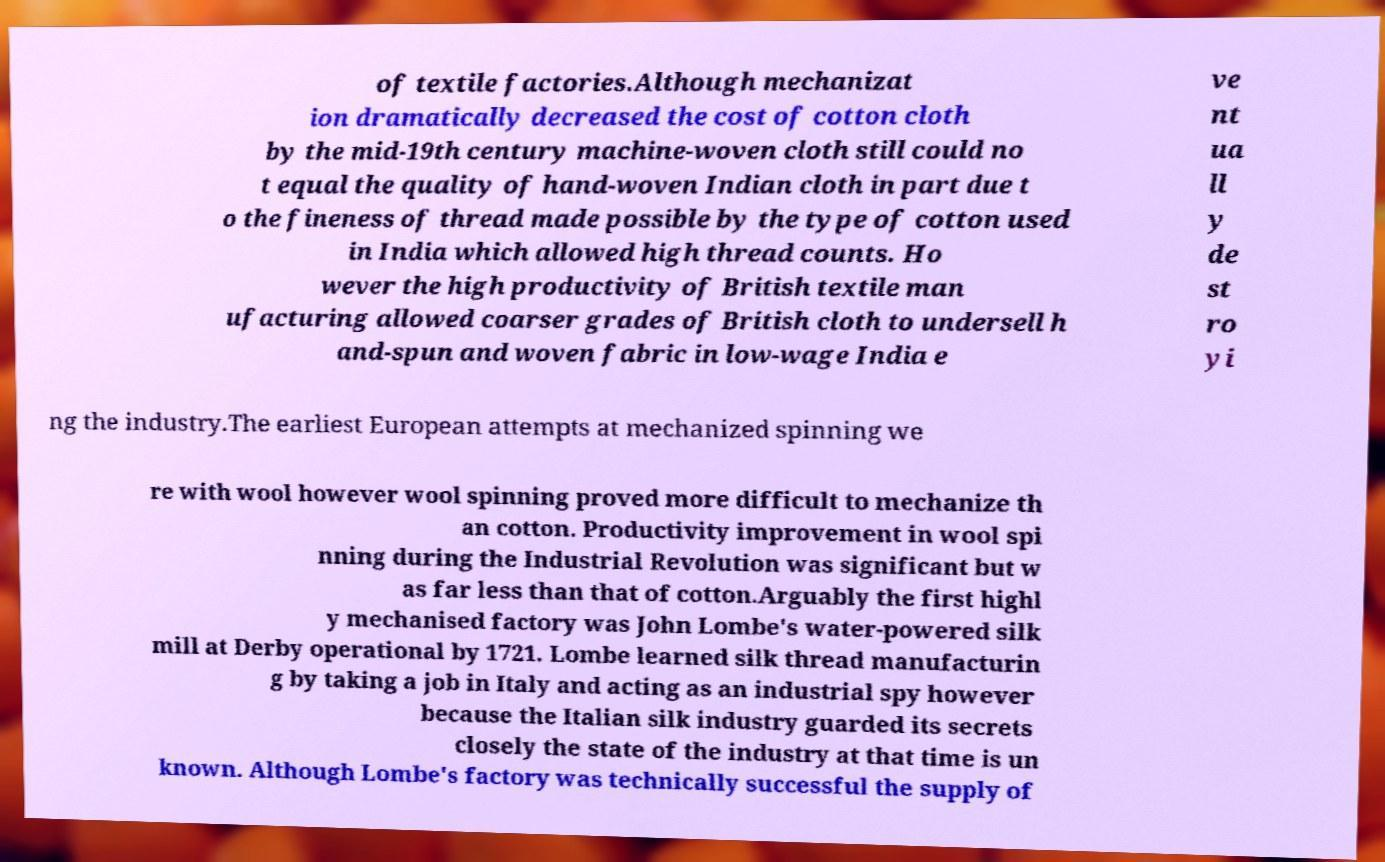What messages or text are displayed in this image? I need them in a readable, typed format. of textile factories.Although mechanizat ion dramatically decreased the cost of cotton cloth by the mid-19th century machine-woven cloth still could no t equal the quality of hand-woven Indian cloth in part due t o the fineness of thread made possible by the type of cotton used in India which allowed high thread counts. Ho wever the high productivity of British textile man ufacturing allowed coarser grades of British cloth to undersell h and-spun and woven fabric in low-wage India e ve nt ua ll y de st ro yi ng the industry.The earliest European attempts at mechanized spinning we re with wool however wool spinning proved more difficult to mechanize th an cotton. Productivity improvement in wool spi nning during the Industrial Revolution was significant but w as far less than that of cotton.Arguably the first highl y mechanised factory was John Lombe's water-powered silk mill at Derby operational by 1721. Lombe learned silk thread manufacturin g by taking a job in Italy and acting as an industrial spy however because the Italian silk industry guarded its secrets closely the state of the industry at that time is un known. Although Lombe's factory was technically successful the supply of 